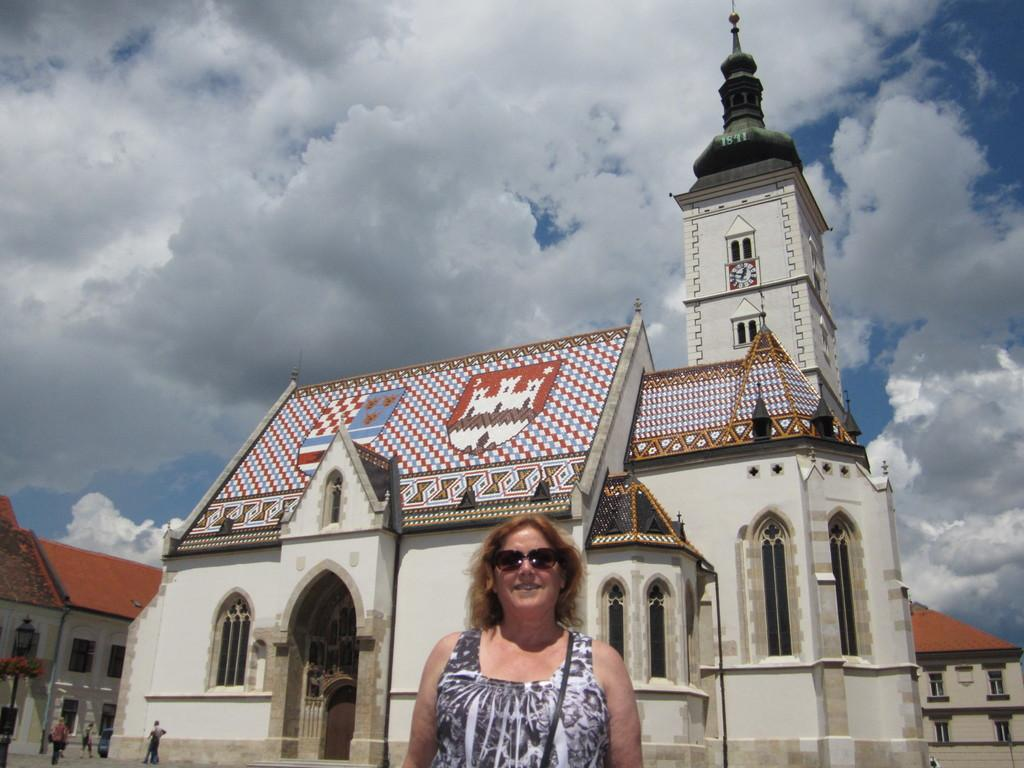How many people are in the image? There are people in the image, but the exact number is not specified. What is the woman in the front wearing? The woman in the front is wearing black color shades. What can be seen in the background of the image? There are buildings, the sky, and other objects visible in the background of the image. What type of rod is being used to climb the slope in the image? There is no rod or slope present in the image. How many forks are visible in the image? There are no forks visible in the image. 